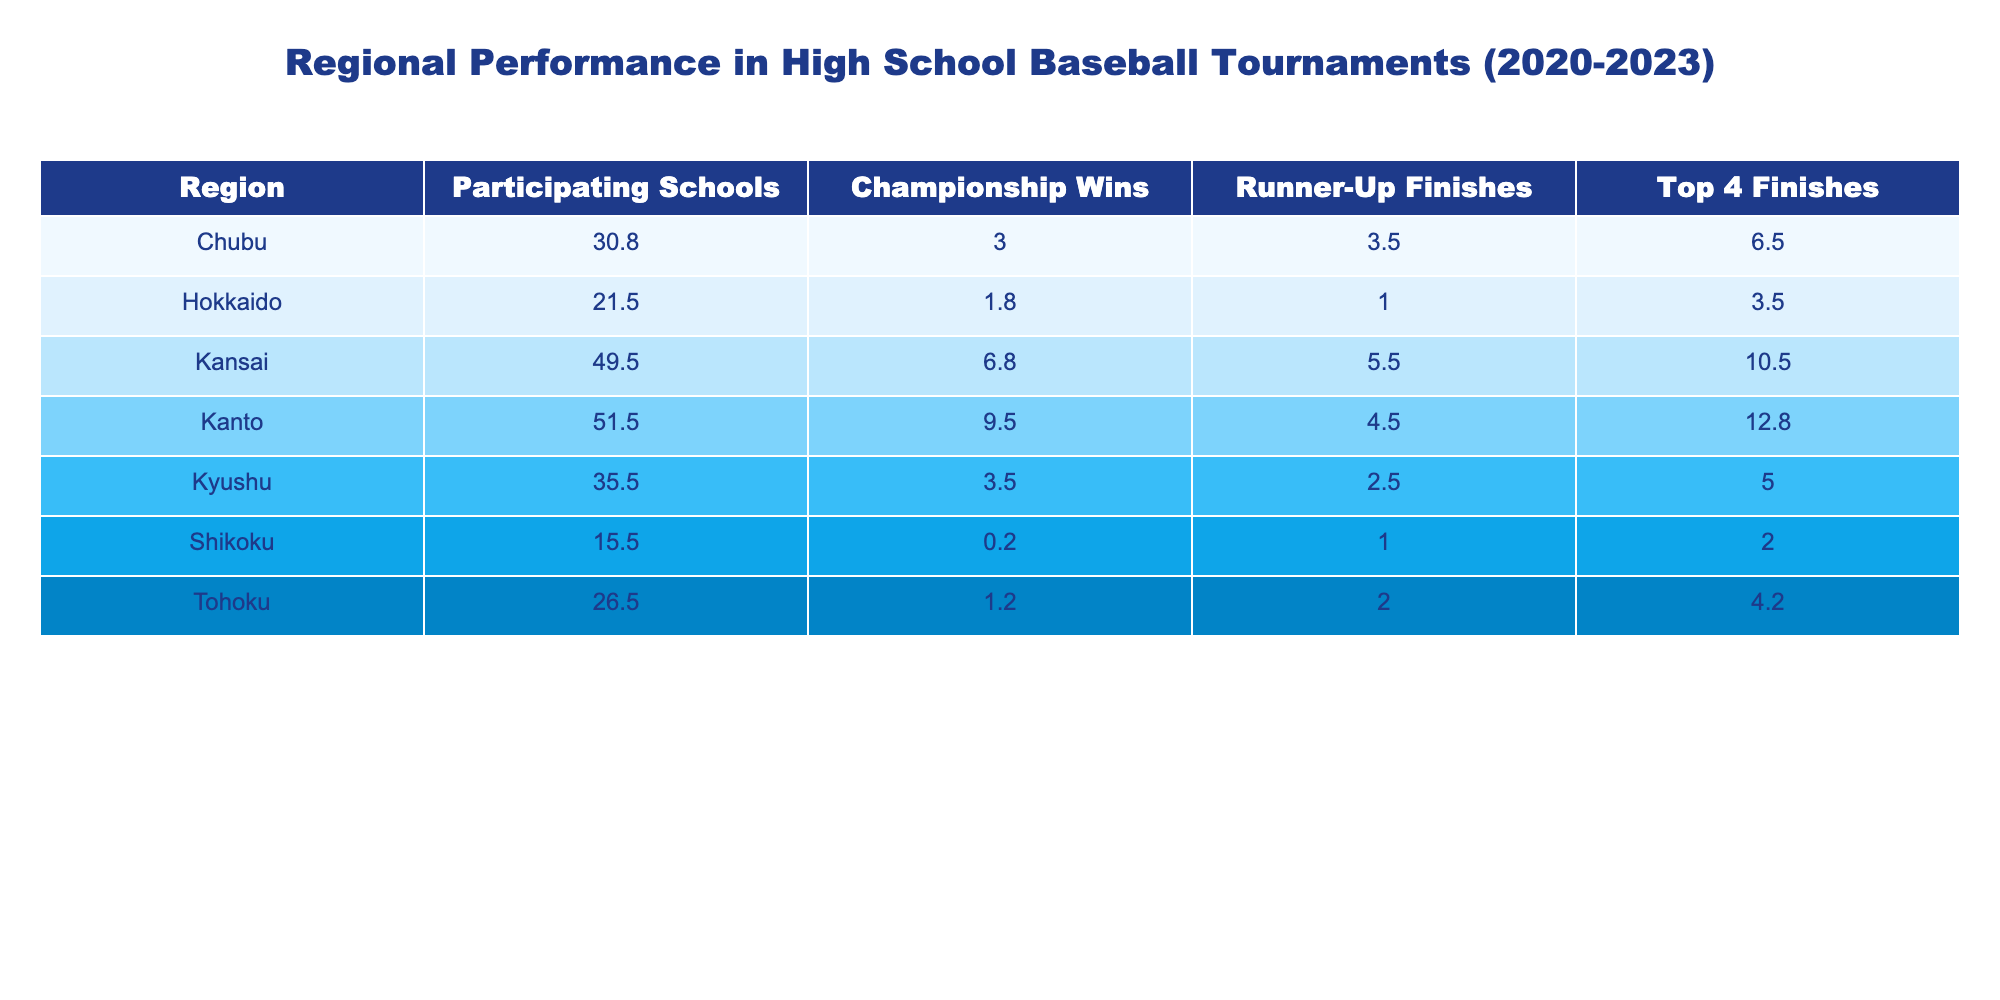What region had the highest average championship wins between 2020 and 2023? To find the region with the highest average championship wins, I will calculate the average for each region. Kanto: (10 + 8 + 9 + 11) / 4 = 9.5, Kansai: (7 + 5 + 9 + 6) / 4 = 6.75, Chubu: (3 + 4 + 2 + 3) / 4 = 3, Tohoku: (2 + 1 + 2 + 0) / 4 = 1.25, Hokkaido: (1 + 2 + 1 + 3) / 4 = 1.75, Shikoku: (0 + 1 + 0 + 0) / 4 = 0.25, Kyushu: (4 + 3 + 5 + 2) / 4 = 3.5. Kanto has the highest average at 9.5.
Answer: Kanto What is the total number of runner-up finishes for Kansai from 2020 to 2023? To find the total runner-up finishes for Kansai, I will sum the runner-up finishes for each year. In 2020, it was 6, in 2021 it was 7, in 2022 it was 4, and in 2023 it was 5. The total is 6 + 7 + 4 + 5 = 22.
Answer: 22 Did Chubu have more top 4 finishes than Hokkaido in 2022? In 2022, Chubu had 7 top 4 finishes and Hokkaido had 3. Since 7 is greater than 3, the answer is yes.
Answer: Yes What is the average number of participating schools across all regions for the year 2023? The number of participating schools in 2023 for each region is: Kanto (53), Kansai (51), Chubu (30), Tohoku (28), Hokkaido (23), Shikoku (16), Kyushu (37). To find the average, I sum them: 53 + 51 + 30 + 28 + 23 + 16 + 37 = 238. There are 7 regions, so the average is 238 / 7 ≈ 34.0.
Answer: 34.0 Which region had the least number of championship wins in 2021? In 2021, I will check the championship wins for each region: Kanto (8), Kansai (5), Chubu (4), Tohoku (1), Hokkaido (2), Shikoku (1), Kyushu (3). The least number of wins is Tohoku with 1.
Answer: Tohoku In which year did Kyushu have its highest number of runner-up finishes? I will check the runner-up finishes for Kyushu over the years: 2020 (2), 2021 (3), 2022 (1), and 2023 (4). The highest number of runner-up finishes is in 2023 with 4 finishes.
Answer: 2023 What is the difference between the average top 4 finishes of Kanto and Kansai? First, I need to calculate the averages for both regions. Kanto had top 4 finishes of 15, 14, 10, and 12 giving an average of (15 + 14 + 10 + 12) / 4 = 12.75. Kansai had top 4 finishes of 10, 8, 11, and 13 giving an average of (10 + 8 + 11 + 13) / 4 = 10.5. The difference is 12.75 - 10.5 = 2.25.
Answer: 2.25 Which region improved the most in championship wins from 2020 to 2023? For each region, I will calculate the change in championship wins from 2020 to 2023. Kanto: 10 to 11 (+1), Kansai: 7 to 6 (-1), Chubu: 3 to 3 (0), Tohoku: 2 to 0 (-2), Hokkaido: 1 to 3 (+2), Shikoku: 0 to 0 (0), Kyushu: 4 to 2 (-2). The most improvement is by Hokkaido with +2 wins.
Answer: Hokkaido 